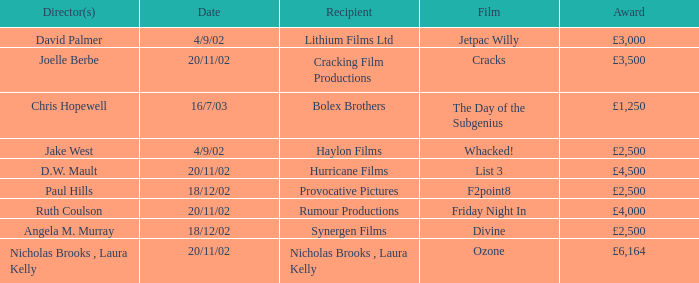What award did the film Ozone win? £6,164. 